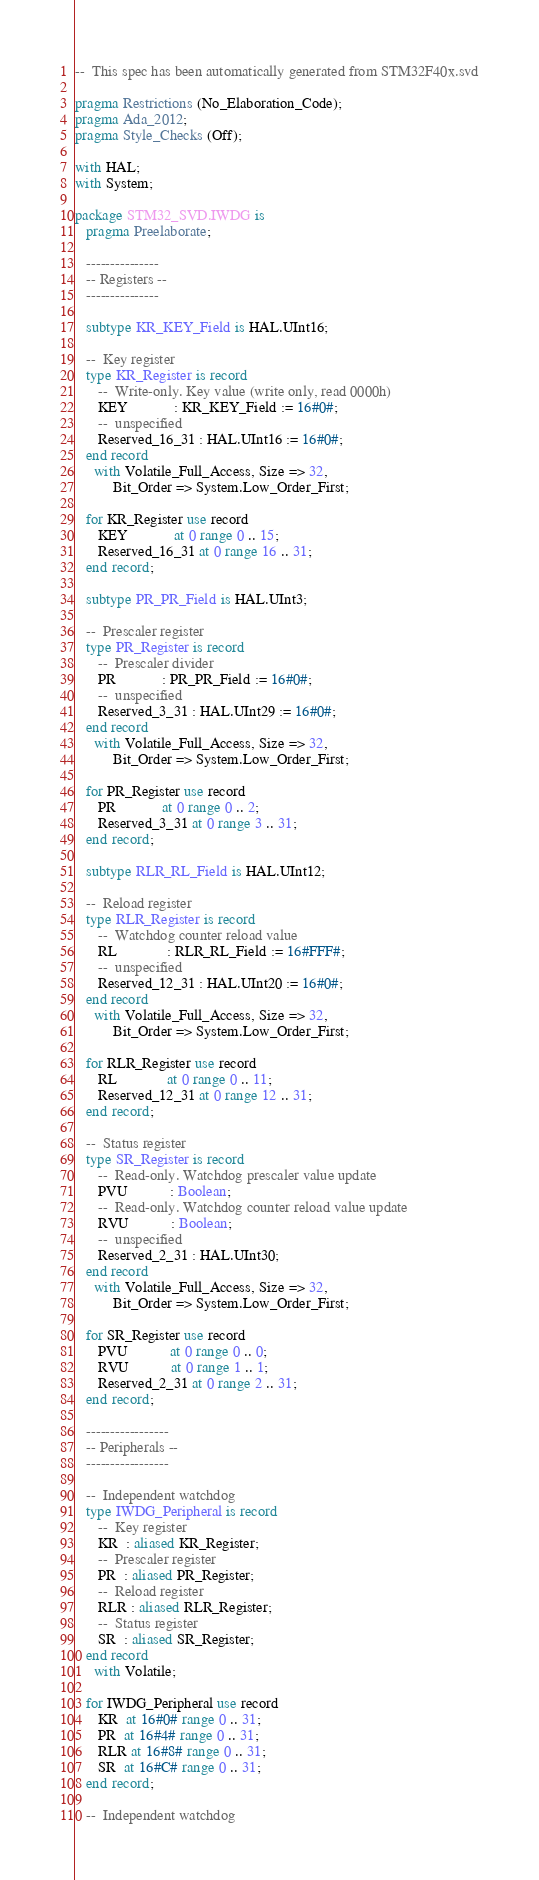Convert code to text. <code><loc_0><loc_0><loc_500><loc_500><_Ada_>--  This spec has been automatically generated from STM32F40x.svd

pragma Restrictions (No_Elaboration_Code);
pragma Ada_2012;
pragma Style_Checks (Off);

with HAL;
with System;

package STM32_SVD.IWDG is
   pragma Preelaborate;

   ---------------
   -- Registers --
   ---------------

   subtype KR_KEY_Field is HAL.UInt16;

   --  Key register
   type KR_Register is record
      --  Write-only. Key value (write only, read 0000h)
      KEY            : KR_KEY_Field := 16#0#;
      --  unspecified
      Reserved_16_31 : HAL.UInt16 := 16#0#;
   end record
     with Volatile_Full_Access, Size => 32,
          Bit_Order => System.Low_Order_First;

   for KR_Register use record
      KEY            at 0 range 0 .. 15;
      Reserved_16_31 at 0 range 16 .. 31;
   end record;

   subtype PR_PR_Field is HAL.UInt3;

   --  Prescaler register
   type PR_Register is record
      --  Prescaler divider
      PR            : PR_PR_Field := 16#0#;
      --  unspecified
      Reserved_3_31 : HAL.UInt29 := 16#0#;
   end record
     with Volatile_Full_Access, Size => 32,
          Bit_Order => System.Low_Order_First;

   for PR_Register use record
      PR            at 0 range 0 .. 2;
      Reserved_3_31 at 0 range 3 .. 31;
   end record;

   subtype RLR_RL_Field is HAL.UInt12;

   --  Reload register
   type RLR_Register is record
      --  Watchdog counter reload value
      RL             : RLR_RL_Field := 16#FFF#;
      --  unspecified
      Reserved_12_31 : HAL.UInt20 := 16#0#;
   end record
     with Volatile_Full_Access, Size => 32,
          Bit_Order => System.Low_Order_First;

   for RLR_Register use record
      RL             at 0 range 0 .. 11;
      Reserved_12_31 at 0 range 12 .. 31;
   end record;

   --  Status register
   type SR_Register is record
      --  Read-only. Watchdog prescaler value update
      PVU           : Boolean;
      --  Read-only. Watchdog counter reload value update
      RVU           : Boolean;
      --  unspecified
      Reserved_2_31 : HAL.UInt30;
   end record
     with Volatile_Full_Access, Size => 32,
          Bit_Order => System.Low_Order_First;

   for SR_Register use record
      PVU           at 0 range 0 .. 0;
      RVU           at 0 range 1 .. 1;
      Reserved_2_31 at 0 range 2 .. 31;
   end record;

   -----------------
   -- Peripherals --
   -----------------

   --  Independent watchdog
   type IWDG_Peripheral is record
      --  Key register
      KR  : aliased KR_Register;
      --  Prescaler register
      PR  : aliased PR_Register;
      --  Reload register
      RLR : aliased RLR_Register;
      --  Status register
      SR  : aliased SR_Register;
   end record
     with Volatile;

   for IWDG_Peripheral use record
      KR  at 16#0# range 0 .. 31;
      PR  at 16#4# range 0 .. 31;
      RLR at 16#8# range 0 .. 31;
      SR  at 16#C# range 0 .. 31;
   end record;

   --  Independent watchdog</code> 